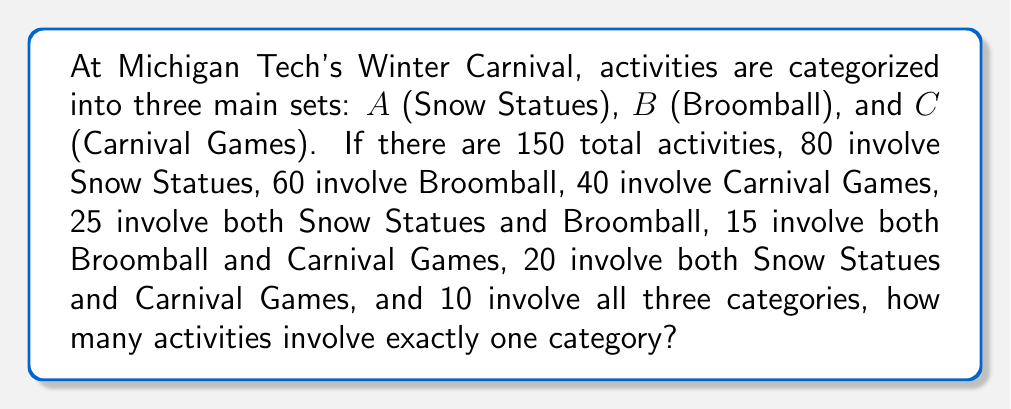Help me with this question. Let's approach this problem using set theory:

1) First, let's define our universal set U as all Winter Carnival activities:
   $|U| = 150$

2) We're given:
   $|A| = 80$, $|B| = 60$, $|C| = 40$
   $|A \cap B| = 25$, $|B \cap C| = 15$, $|A \cap C| = 20$
   $|A \cap B \cap C| = 10$

3) We can use the Inclusion-Exclusion Principle to find $|A \cup B \cup C|$:
   
   $|A \cup B \cup C| = |A| + |B| + |C| - |A \cap B| - |B \cap C| - |A \cap C| + |A \cap B \cap C|$
   
   $= 80 + 60 + 40 - 25 - 15 - 20 + 10 = 130$

4) The number of activities involving at least one category is 130.

5) Therefore, the number of activities involving no categories is:
   $150 - 130 = 20$

6) Now, let's find the number of activities involving exactly one category:
   
   Let $x$ be the number of activities involving exactly one category.
   
   $x + |A \cap B| + |B \cap C| + |A \cap C| - 2|A \cap B \cap C| = |A \cup B \cup C|$
   
   $x + 25 + 15 + 20 - 2(10) = 130$
   
   $x + 40 = 130$
   
   $x = 90$

Thus, 90 activities involve exactly one category.
Answer: 90 activities 